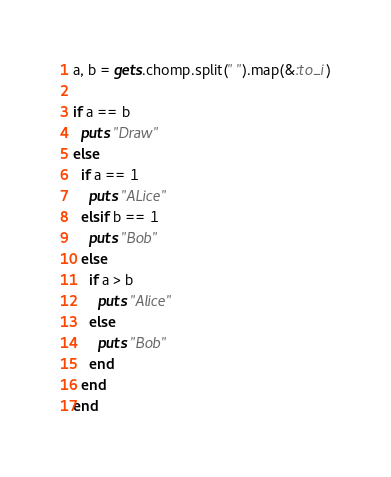<code> <loc_0><loc_0><loc_500><loc_500><_Ruby_>a, b = gets.chomp.split(" ").map(&:to_i)

if a == b
  puts "Draw"
else
  if a == 1
    puts "ALice"
  elsif b == 1
    puts "Bob"
  else
    if a > b
      puts "Alice"
    else
      puts "Bob"
    end
  end
end</code> 